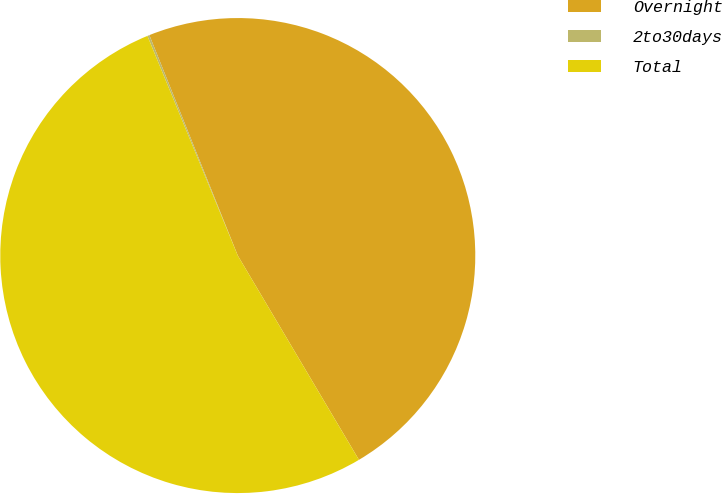<chart> <loc_0><loc_0><loc_500><loc_500><pie_chart><fcel>Overnight<fcel>2to30days<fcel>Total<nl><fcel>47.55%<fcel>0.14%<fcel>52.31%<nl></chart> 